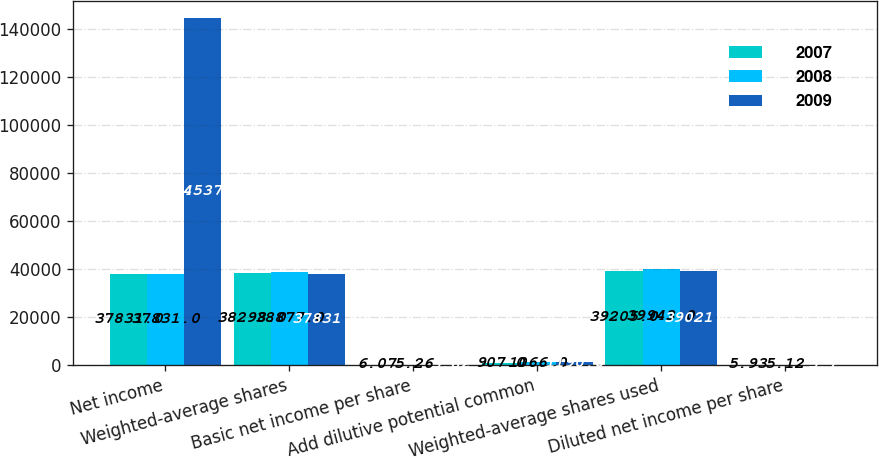<chart> <loc_0><loc_0><loc_500><loc_500><stacked_bar_chart><ecel><fcel>Net income<fcel>Weighted-average shares<fcel>Basic net income per share<fcel>Add dilutive potential common<fcel>Weighted-average shares used<fcel>Diluted net income per share<nl><fcel>2007<fcel>37831<fcel>38298<fcel>6.07<fcel>907<fcel>39205<fcel>5.93<nl><fcel>2008<fcel>37831<fcel>38877<fcel>5.26<fcel>1066<fcel>39943<fcel>5.12<nl><fcel>2009<fcel>144537<fcel>37831<fcel>3.82<fcel>1190<fcel>39021<fcel>3.7<nl></chart> 